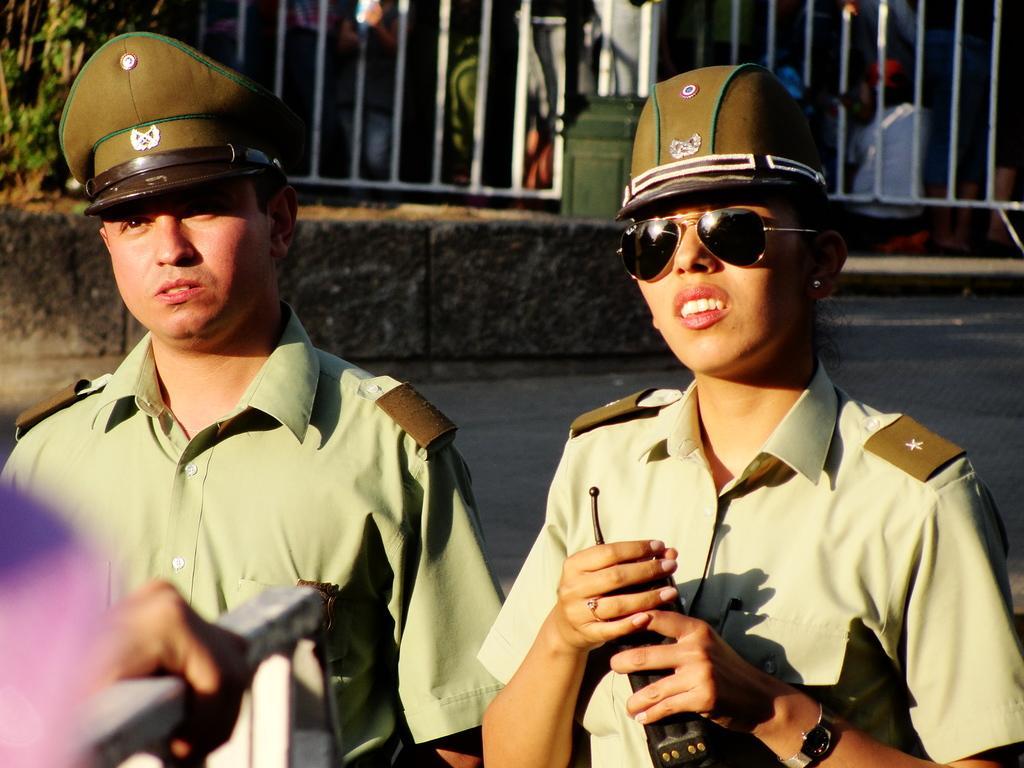Could you give a brief overview of what you see in this image? In this picture we can see a man and woman, they are holding some devices, they are wearing caps, woman is wearing a goggles and in the background we can see a fence, road, people, plants and some objects. 